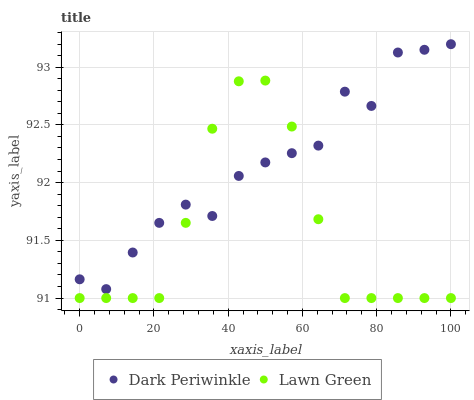Does Lawn Green have the minimum area under the curve?
Answer yes or no. Yes. Does Dark Periwinkle have the maximum area under the curve?
Answer yes or no. Yes. Does Dark Periwinkle have the minimum area under the curve?
Answer yes or no. No. Is Lawn Green the smoothest?
Answer yes or no. Yes. Is Dark Periwinkle the roughest?
Answer yes or no. Yes. Is Dark Periwinkle the smoothest?
Answer yes or no. No. Does Lawn Green have the lowest value?
Answer yes or no. Yes. Does Dark Periwinkle have the lowest value?
Answer yes or no. No. Does Dark Periwinkle have the highest value?
Answer yes or no. Yes. Does Dark Periwinkle intersect Lawn Green?
Answer yes or no. Yes. Is Dark Periwinkle less than Lawn Green?
Answer yes or no. No. Is Dark Periwinkle greater than Lawn Green?
Answer yes or no. No. 